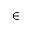Convert formula to latex. <formula><loc_0><loc_0><loc_500><loc_500>\in</formula> 